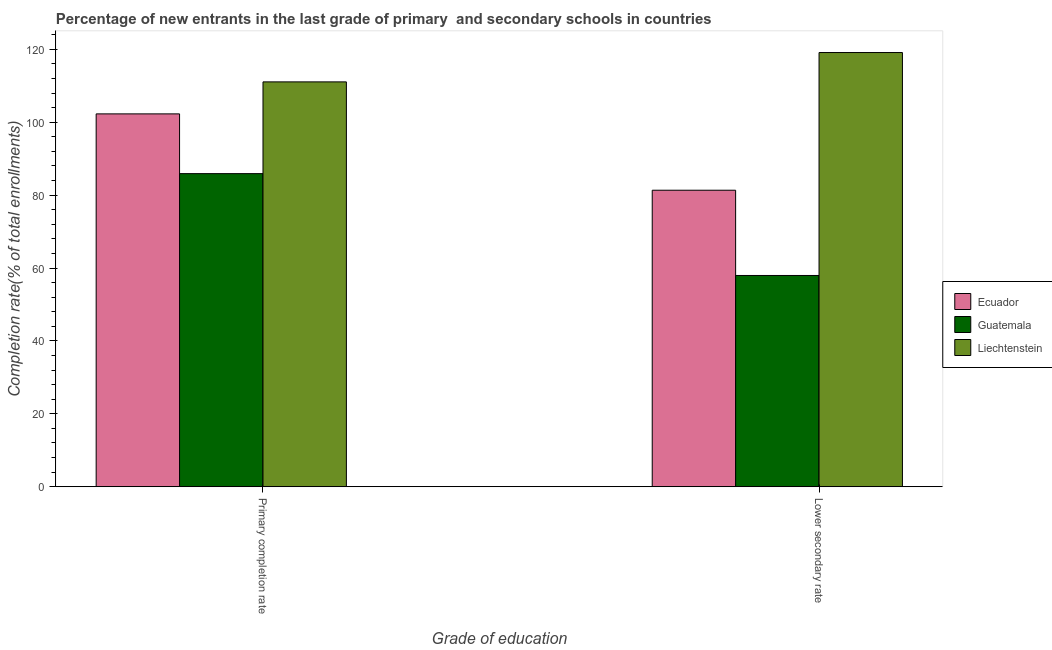How many different coloured bars are there?
Make the answer very short. 3. How many groups of bars are there?
Provide a succinct answer. 2. How many bars are there on the 1st tick from the left?
Offer a terse response. 3. How many bars are there on the 1st tick from the right?
Make the answer very short. 3. What is the label of the 2nd group of bars from the left?
Your response must be concise. Lower secondary rate. What is the completion rate in primary schools in Ecuador?
Provide a succinct answer. 102.28. Across all countries, what is the maximum completion rate in primary schools?
Your answer should be very brief. 111.05. Across all countries, what is the minimum completion rate in primary schools?
Provide a short and direct response. 85.89. In which country was the completion rate in primary schools maximum?
Provide a succinct answer. Liechtenstein. In which country was the completion rate in primary schools minimum?
Give a very brief answer. Guatemala. What is the total completion rate in secondary schools in the graph?
Provide a succinct answer. 258.4. What is the difference between the completion rate in primary schools in Guatemala and that in Liechtenstein?
Provide a succinct answer. -25.17. What is the difference between the completion rate in primary schools in Liechtenstein and the completion rate in secondary schools in Guatemala?
Offer a very short reply. 53.1. What is the average completion rate in primary schools per country?
Offer a terse response. 99.74. What is the difference between the completion rate in secondary schools and completion rate in primary schools in Guatemala?
Offer a very short reply. -27.94. In how many countries, is the completion rate in secondary schools greater than 48 %?
Provide a succinct answer. 3. What is the ratio of the completion rate in secondary schools in Ecuador to that in Liechtenstein?
Ensure brevity in your answer.  0.68. Is the completion rate in primary schools in Liechtenstein less than that in Ecuador?
Offer a terse response. No. What does the 3rd bar from the left in Primary completion rate represents?
Your response must be concise. Liechtenstein. What does the 1st bar from the right in Lower secondary rate represents?
Ensure brevity in your answer.  Liechtenstein. How many bars are there?
Provide a short and direct response. 6. Are the values on the major ticks of Y-axis written in scientific E-notation?
Give a very brief answer. No. Does the graph contain grids?
Give a very brief answer. No. How many legend labels are there?
Provide a succinct answer. 3. How are the legend labels stacked?
Make the answer very short. Vertical. What is the title of the graph?
Keep it short and to the point. Percentage of new entrants in the last grade of primary  and secondary schools in countries. Does "Sub-Saharan Africa (all income levels)" appear as one of the legend labels in the graph?
Your response must be concise. No. What is the label or title of the X-axis?
Offer a very short reply. Grade of education. What is the label or title of the Y-axis?
Make the answer very short. Completion rate(% of total enrollments). What is the Completion rate(% of total enrollments) in Ecuador in Primary completion rate?
Your answer should be very brief. 102.28. What is the Completion rate(% of total enrollments) of Guatemala in Primary completion rate?
Your answer should be very brief. 85.89. What is the Completion rate(% of total enrollments) in Liechtenstein in Primary completion rate?
Keep it short and to the point. 111.05. What is the Completion rate(% of total enrollments) of Ecuador in Lower secondary rate?
Make the answer very short. 81.34. What is the Completion rate(% of total enrollments) of Guatemala in Lower secondary rate?
Ensure brevity in your answer.  57.95. What is the Completion rate(% of total enrollments) in Liechtenstein in Lower secondary rate?
Give a very brief answer. 119.11. Across all Grade of education, what is the maximum Completion rate(% of total enrollments) of Ecuador?
Give a very brief answer. 102.28. Across all Grade of education, what is the maximum Completion rate(% of total enrollments) of Guatemala?
Keep it short and to the point. 85.89. Across all Grade of education, what is the maximum Completion rate(% of total enrollments) of Liechtenstein?
Give a very brief answer. 119.11. Across all Grade of education, what is the minimum Completion rate(% of total enrollments) of Ecuador?
Provide a short and direct response. 81.34. Across all Grade of education, what is the minimum Completion rate(% of total enrollments) in Guatemala?
Offer a terse response. 57.95. Across all Grade of education, what is the minimum Completion rate(% of total enrollments) in Liechtenstein?
Ensure brevity in your answer.  111.05. What is the total Completion rate(% of total enrollments) in Ecuador in the graph?
Keep it short and to the point. 183.61. What is the total Completion rate(% of total enrollments) in Guatemala in the graph?
Keep it short and to the point. 143.84. What is the total Completion rate(% of total enrollments) of Liechtenstein in the graph?
Your answer should be very brief. 230.16. What is the difference between the Completion rate(% of total enrollments) of Ecuador in Primary completion rate and that in Lower secondary rate?
Ensure brevity in your answer.  20.94. What is the difference between the Completion rate(% of total enrollments) of Guatemala in Primary completion rate and that in Lower secondary rate?
Make the answer very short. 27.94. What is the difference between the Completion rate(% of total enrollments) in Liechtenstein in Primary completion rate and that in Lower secondary rate?
Your answer should be compact. -8.05. What is the difference between the Completion rate(% of total enrollments) in Ecuador in Primary completion rate and the Completion rate(% of total enrollments) in Guatemala in Lower secondary rate?
Your answer should be compact. 44.33. What is the difference between the Completion rate(% of total enrollments) in Ecuador in Primary completion rate and the Completion rate(% of total enrollments) in Liechtenstein in Lower secondary rate?
Your response must be concise. -16.83. What is the difference between the Completion rate(% of total enrollments) in Guatemala in Primary completion rate and the Completion rate(% of total enrollments) in Liechtenstein in Lower secondary rate?
Provide a short and direct response. -33.22. What is the average Completion rate(% of total enrollments) of Ecuador per Grade of education?
Your answer should be very brief. 91.81. What is the average Completion rate(% of total enrollments) of Guatemala per Grade of education?
Your response must be concise. 71.92. What is the average Completion rate(% of total enrollments) in Liechtenstein per Grade of education?
Offer a terse response. 115.08. What is the difference between the Completion rate(% of total enrollments) in Ecuador and Completion rate(% of total enrollments) in Guatemala in Primary completion rate?
Give a very brief answer. 16.39. What is the difference between the Completion rate(% of total enrollments) in Ecuador and Completion rate(% of total enrollments) in Liechtenstein in Primary completion rate?
Your answer should be very brief. -8.78. What is the difference between the Completion rate(% of total enrollments) in Guatemala and Completion rate(% of total enrollments) in Liechtenstein in Primary completion rate?
Your answer should be compact. -25.17. What is the difference between the Completion rate(% of total enrollments) of Ecuador and Completion rate(% of total enrollments) of Guatemala in Lower secondary rate?
Give a very brief answer. 23.39. What is the difference between the Completion rate(% of total enrollments) in Ecuador and Completion rate(% of total enrollments) in Liechtenstein in Lower secondary rate?
Keep it short and to the point. -37.77. What is the difference between the Completion rate(% of total enrollments) in Guatemala and Completion rate(% of total enrollments) in Liechtenstein in Lower secondary rate?
Provide a short and direct response. -61.16. What is the ratio of the Completion rate(% of total enrollments) in Ecuador in Primary completion rate to that in Lower secondary rate?
Keep it short and to the point. 1.26. What is the ratio of the Completion rate(% of total enrollments) in Guatemala in Primary completion rate to that in Lower secondary rate?
Ensure brevity in your answer.  1.48. What is the ratio of the Completion rate(% of total enrollments) of Liechtenstein in Primary completion rate to that in Lower secondary rate?
Your response must be concise. 0.93. What is the difference between the highest and the second highest Completion rate(% of total enrollments) of Ecuador?
Give a very brief answer. 20.94. What is the difference between the highest and the second highest Completion rate(% of total enrollments) of Guatemala?
Your response must be concise. 27.94. What is the difference between the highest and the second highest Completion rate(% of total enrollments) of Liechtenstein?
Provide a short and direct response. 8.05. What is the difference between the highest and the lowest Completion rate(% of total enrollments) in Ecuador?
Provide a short and direct response. 20.94. What is the difference between the highest and the lowest Completion rate(% of total enrollments) of Guatemala?
Provide a succinct answer. 27.94. What is the difference between the highest and the lowest Completion rate(% of total enrollments) of Liechtenstein?
Make the answer very short. 8.05. 